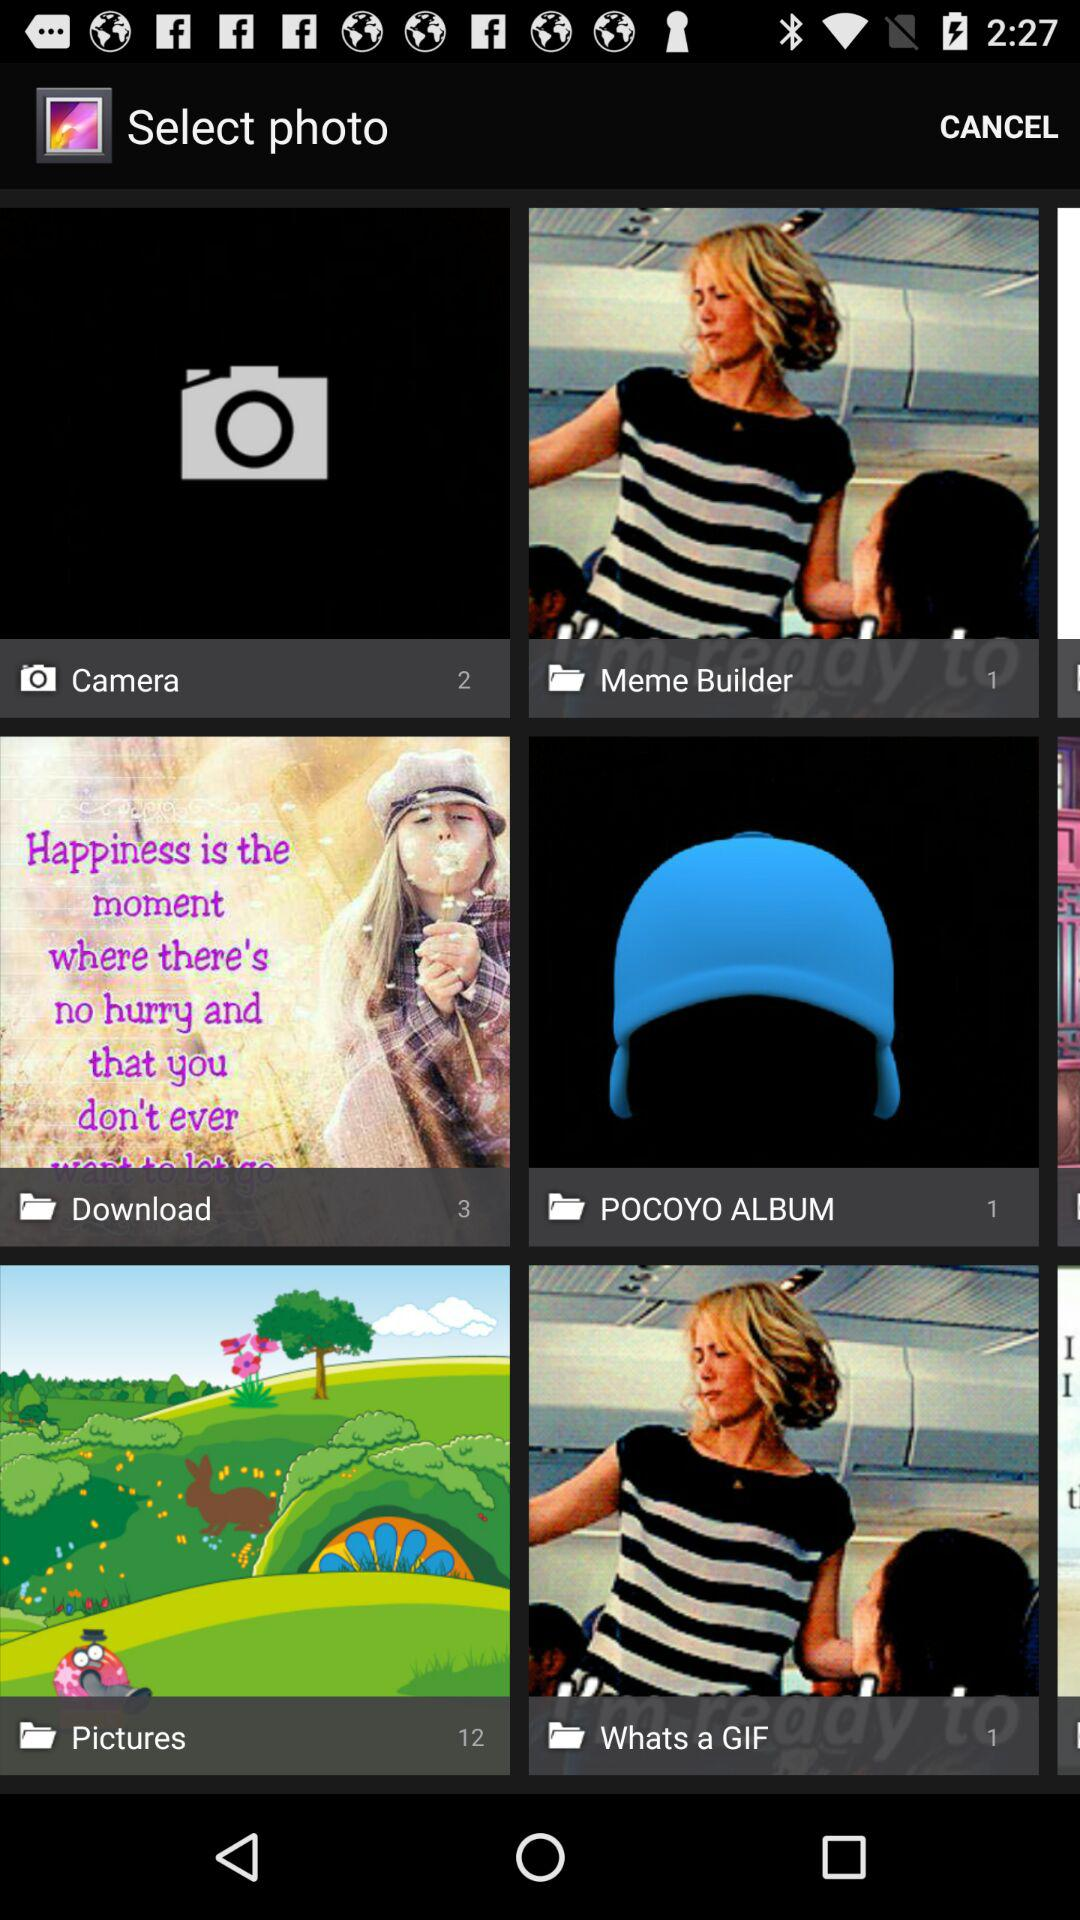How many pictures are in the download folder? There are 3 pictures. 